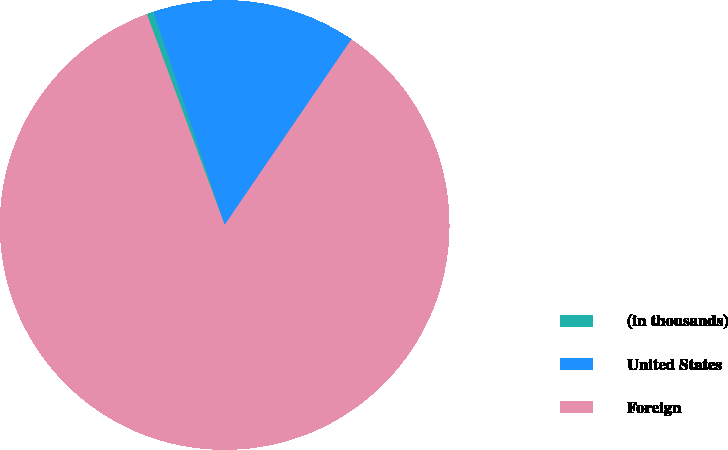Convert chart. <chart><loc_0><loc_0><loc_500><loc_500><pie_chart><fcel>(in thousands)<fcel>United States<fcel>Foreign<nl><fcel>0.5%<fcel>14.67%<fcel>84.83%<nl></chart> 